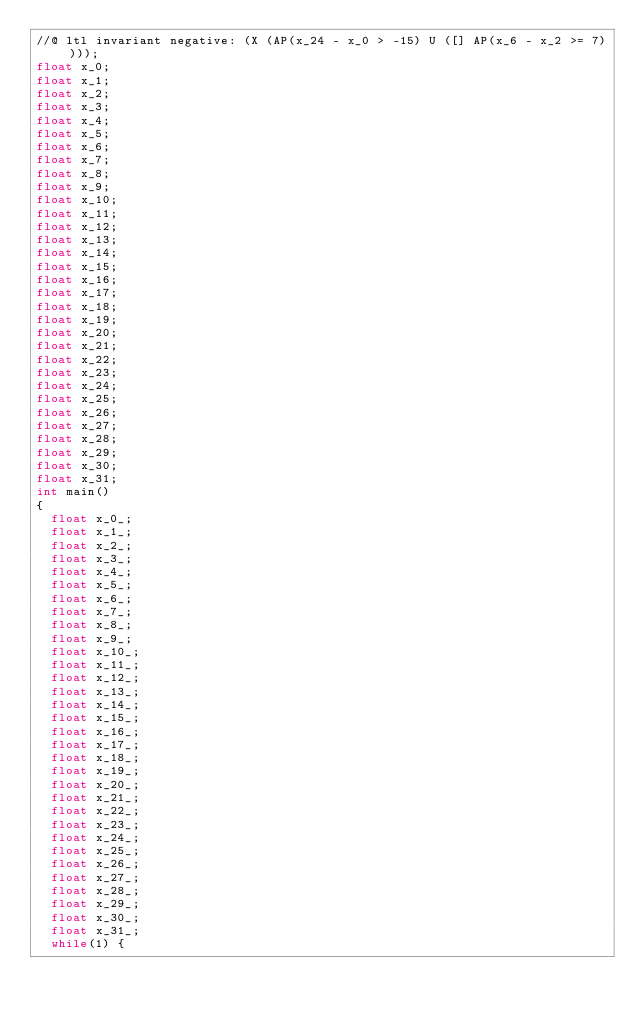<code> <loc_0><loc_0><loc_500><loc_500><_C_>//@ ltl invariant negative: (X (AP(x_24 - x_0 > -15) U ([] AP(x_6 - x_2 >= 7))));
float x_0;
float x_1;
float x_2;
float x_3;
float x_4;
float x_5;
float x_6;
float x_7;
float x_8;
float x_9;
float x_10;
float x_11;
float x_12;
float x_13;
float x_14;
float x_15;
float x_16;
float x_17;
float x_18;
float x_19;
float x_20;
float x_21;
float x_22;
float x_23;
float x_24;
float x_25;
float x_26;
float x_27;
float x_28;
float x_29;
float x_30;
float x_31;
int main()
{
  float x_0_;
  float x_1_;
  float x_2_;
  float x_3_;
  float x_4_;
  float x_5_;
  float x_6_;
  float x_7_;
  float x_8_;
  float x_9_;
  float x_10_;
  float x_11_;
  float x_12_;
  float x_13_;
  float x_14_;
  float x_15_;
  float x_16_;
  float x_17_;
  float x_18_;
  float x_19_;
  float x_20_;
  float x_21_;
  float x_22_;
  float x_23_;
  float x_24_;
  float x_25_;
  float x_26_;
  float x_27_;
  float x_28_;
  float x_29_;
  float x_30_;
  float x_31_;
  while(1) {</code> 